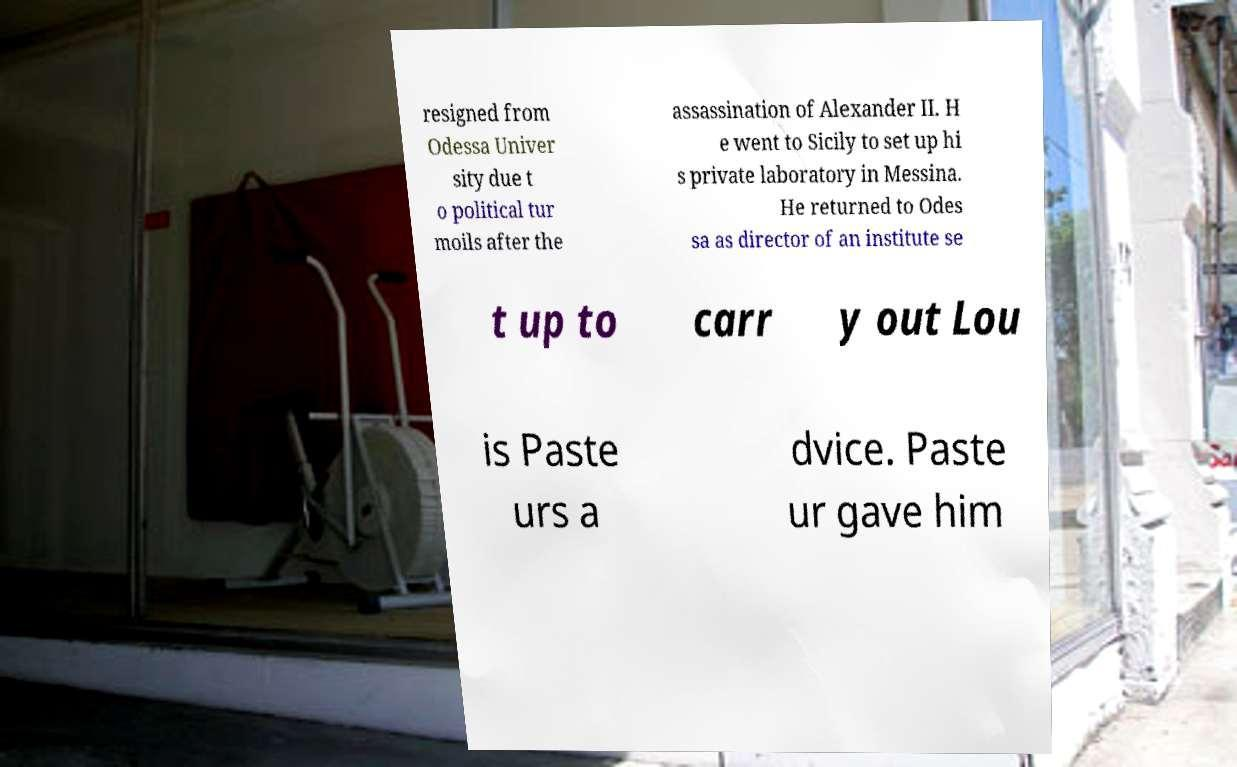Can you accurately transcribe the text from the provided image for me? resigned from Odessa Univer sity due t o political tur moils after the assassination of Alexander II. H e went to Sicily to set up hi s private laboratory in Messina. He returned to Odes sa as director of an institute se t up to carr y out Lou is Paste urs a dvice. Paste ur gave him 